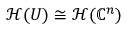<formula> <loc_0><loc_0><loc_500><loc_500>{ \mathcal { H } } ( U ) \cong { \mathcal { H } } ( \mathbb { C } ^ { n } )</formula> 